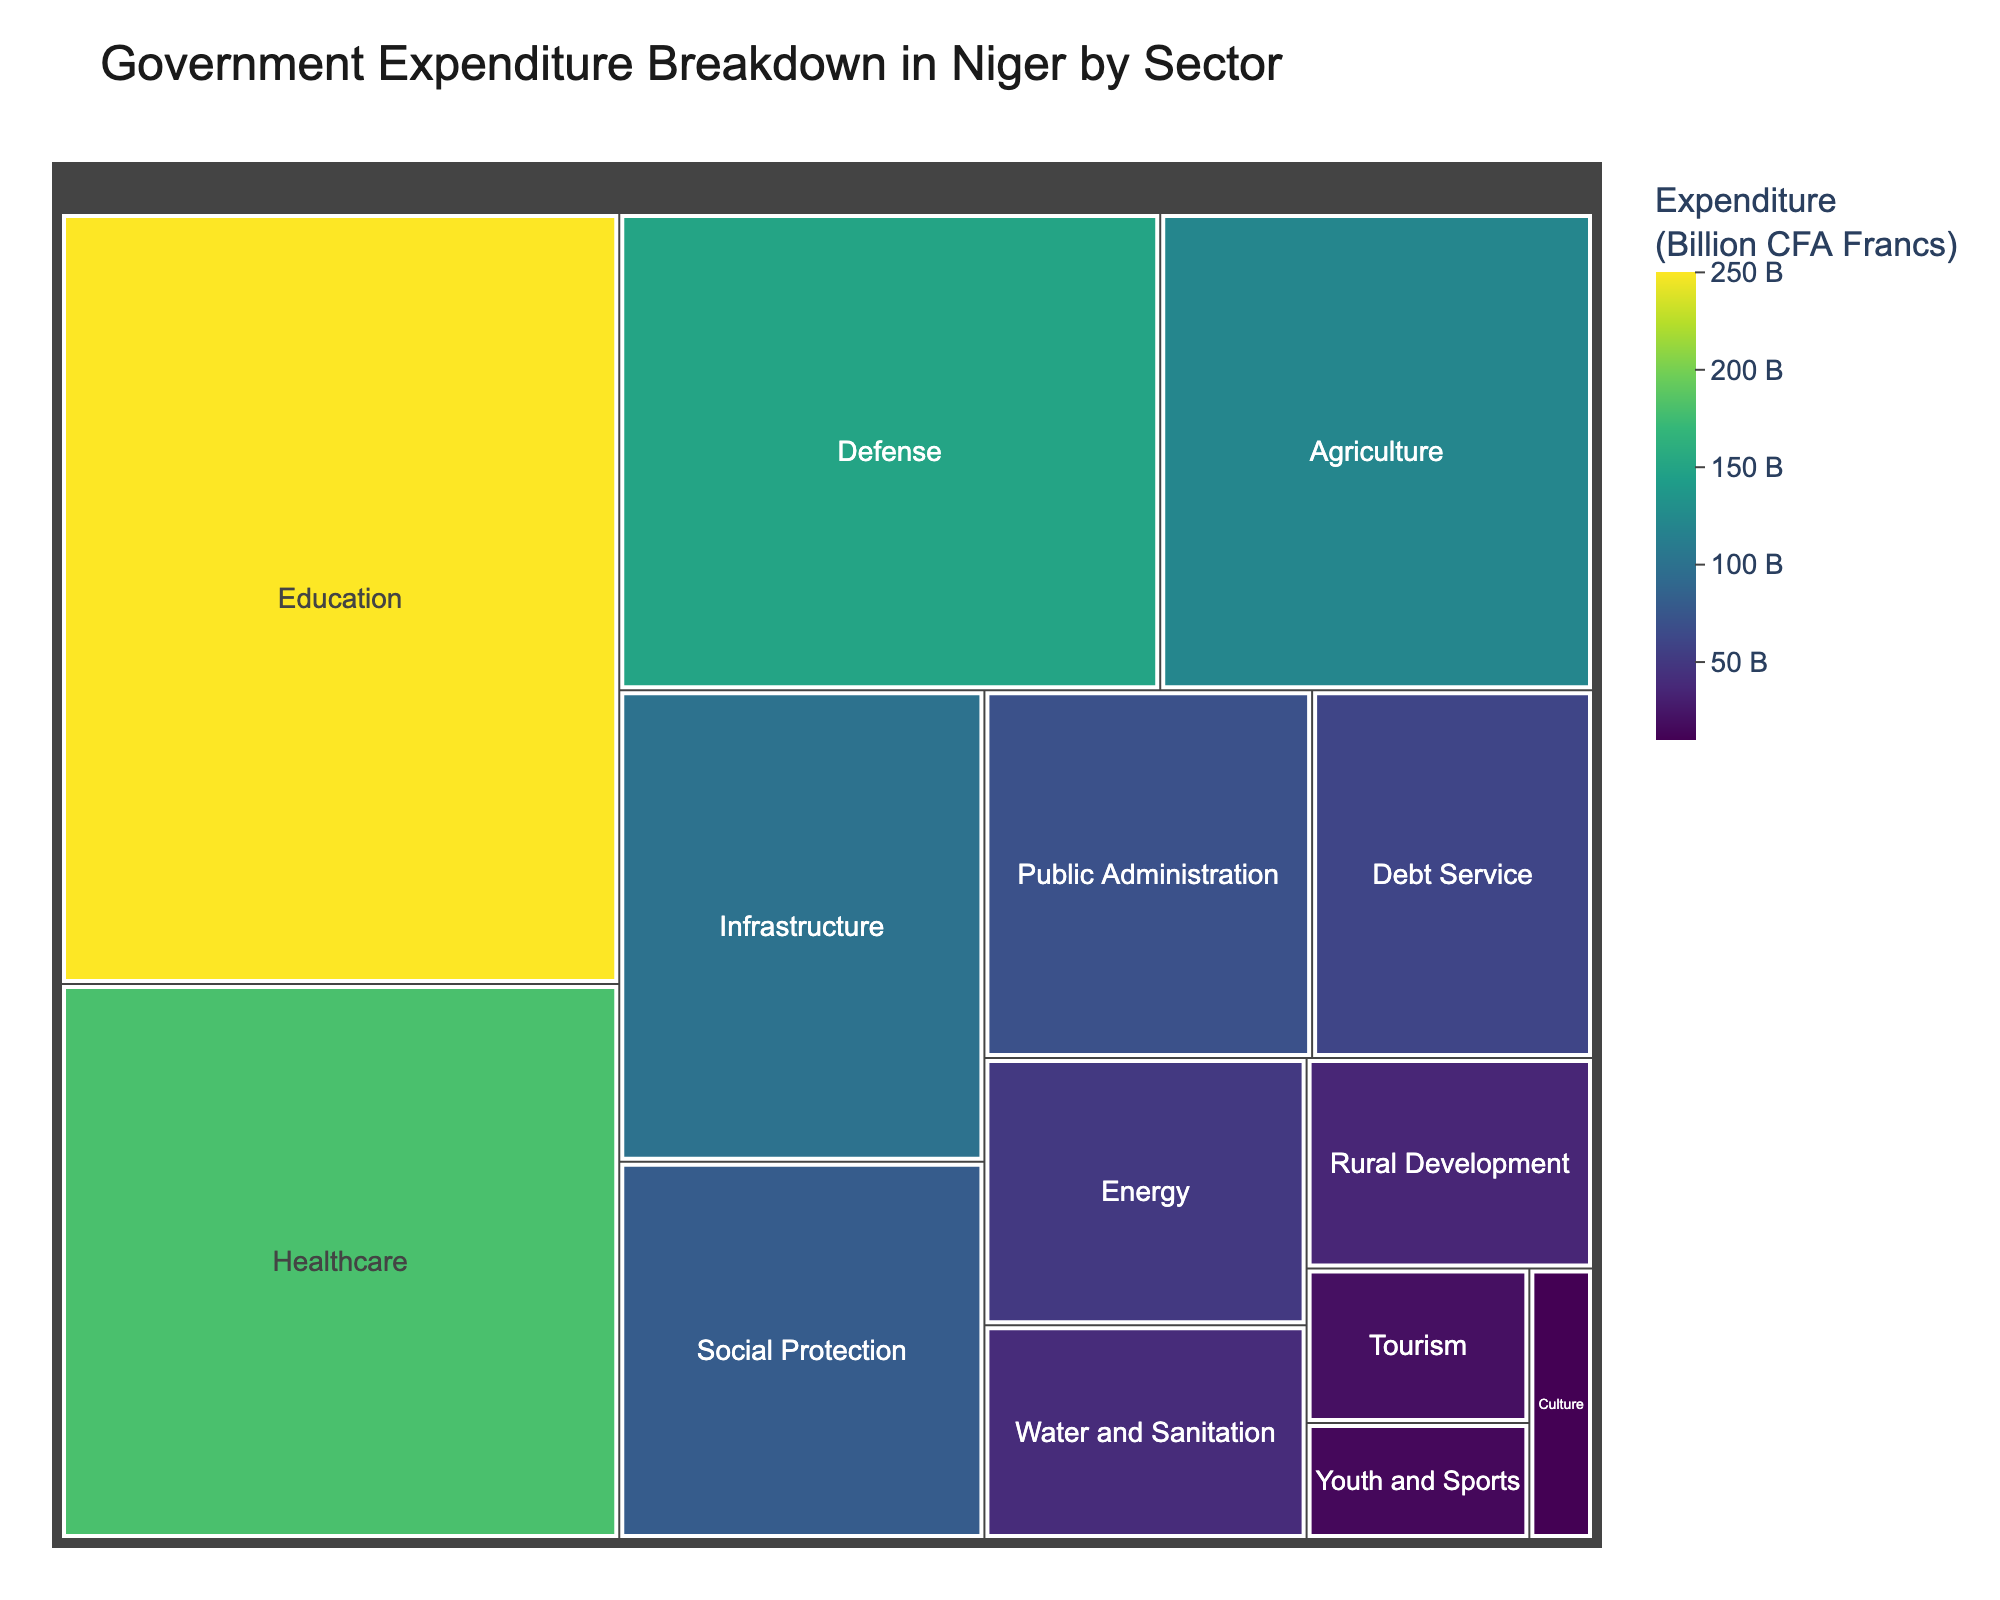What's the biggest sector in terms of expenditure? The biggest sector can be identified by finding the largest block in the treemap, which corresponds to the Education sector with an expenditure of 250 billion CFA Francs.
Answer: Education What is the total expenditure on Defense and Healthcare combined? The expenditures for Defense and Healthcare are 150 and 180 billion CFA Francs, respectively. Adding these two values gives 150 + 180 = 330 billion CFA Francs.
Answer: 330 billion CFA Francs Which sector has the smallest expenditure? The smallest sector can be identified by finding the smallest block in the treemap, which corresponds to the Culture sector with an expenditure of 10 billion CFA Francs.
Answer: Culture How does expenditure on Infrastructure compare to that on Agriculture? The expenditure on Infrastructure is 100 billion CFA Francs, while that on Agriculture is 120 billion CFA Francs. Since 120 is greater than 100, Agriculture has a higher expenditure than Infrastructure.
Answer: Agriculture has a higher expenditure What is the average expenditure of the sectors with amounts above 100 billion CFA Francs? The sectors with expenditures above 100 billion CFA Francs are Education (250), Healthcare (180), Defense (150), and Agriculture (120). Sum these amounts: 250 + 180 + 150 + 120 = 700. There are 4 sectors, so the average is 700 / 4 = 175 billion CFA Francs.
Answer: 175 billion CFA Francs What percentage of the total expenditure is spent on Social Protection? First, find the total expenditure by summing all sectors' expenditures: 250 + 180 + 150 + 120 + 100 + 80 + 70 + 60 + 50 + 40 + 35 + 20 + 15 + 10 = 1180 billion CFA Francs. The expenditure on Social Protection is 80 billion CFA Francs. The percentage is (80 / 1180) * 100 = 6.78%.
Answer: 6.78% Which sectors have an expenditure lower than 50 billion CFA Francs? Identifying the sectors with blocks smaller than 50 billion CFA Francs in the treemap shows Water and Sanitation (40), Rural Development (35), Tourism (20), Youth and Sports (15), and Culture (10).
Answer: Water and Sanitation, Rural Development, Tourism, Youth and Sports, Culture What is the expenditure difference between Energy and Debt Service? The expenditure for Energy is 50 billion CFA Francs, and for Debt Service is 60 billion CFA Francs. The difference is 60 - 50 = 10 billion CFA Francs.
Answer: 10 billion CFA Francs How much more is spent on Public Administration compared to Debt Service? The expenditure for Public Administration is 70 billion CFA Francs, while for Debt Service, it is 60 billion CFA Francs. The difference is 70 - 60 = 10 billion CFA Francs.
Answer: 10 billion CFA Francs What proportion of the total government expenditure is allocated to Education and Healthcare collectively? Adding the expenditures for Education (250) and Healthcare (180) gives 250 + 180 = 430 billion CFA Francs. The total expenditure is 1180 billion CFA Francs. The proportion is (430 / 1180) * 100 = 36.44%.
Answer: 36.44% 